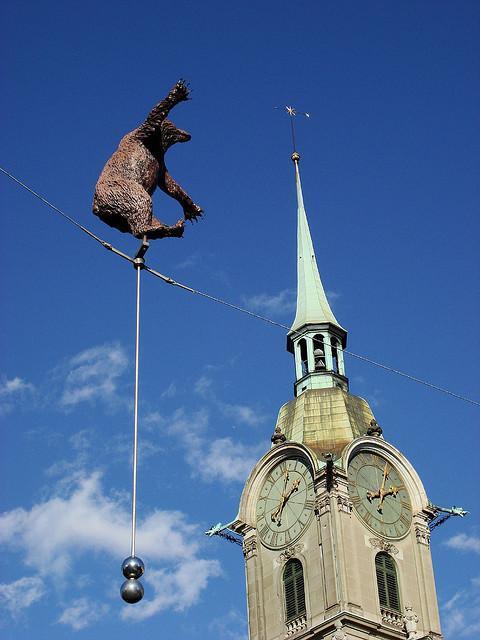How many clocks are visible?
Give a very brief answer. 2. How many bears can be seen?
Give a very brief answer. 1. 